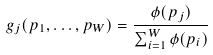<formula> <loc_0><loc_0><loc_500><loc_500>g _ { j } ( p _ { 1 } , \dots , p _ { W } ) = \frac { \phi ( p _ { j } ) } { \sum _ { i = 1 } ^ { W } \phi ( p _ { i } ) }</formula> 